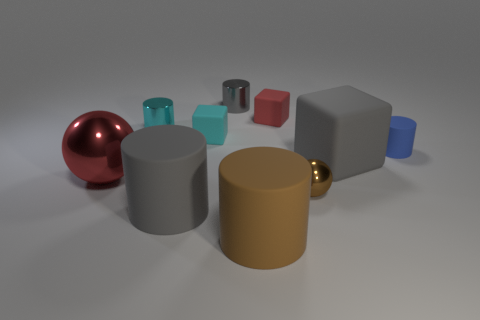Subtract all tiny cylinders. How many cylinders are left? 2 Subtract all red spheres. How many spheres are left? 1 Subtract all blue cubes. How many gray cylinders are left? 2 Subtract 1 spheres. How many spheres are left? 1 Subtract all cubes. How many objects are left? 7 Subtract all cyan spheres. Subtract all brown blocks. How many spheres are left? 2 Subtract all red rubber blocks. Subtract all large yellow spheres. How many objects are left? 9 Add 1 cylinders. How many cylinders are left? 6 Add 2 tiny cyan things. How many tiny cyan things exist? 4 Subtract 1 brown cylinders. How many objects are left? 9 